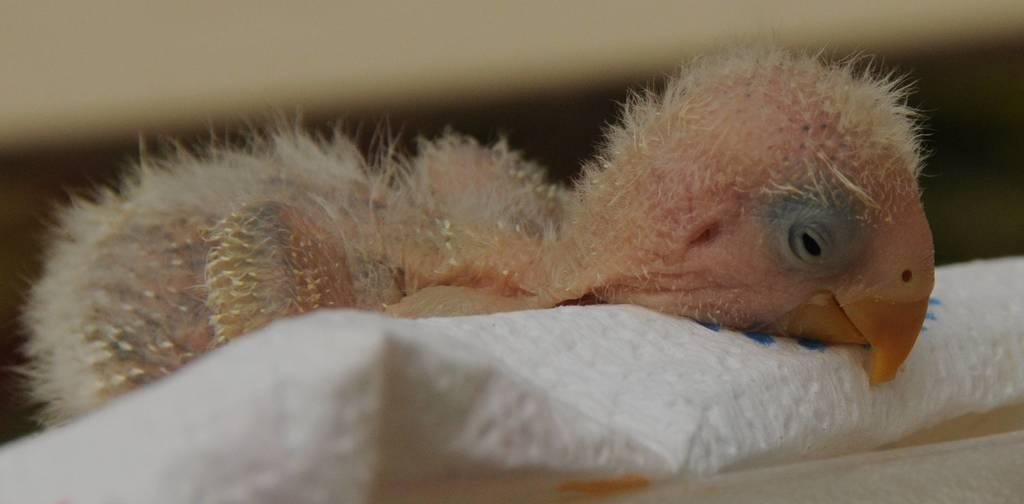What type of animal is in the image? There is a bird in the image. What is the bird standing on in the image? The bird is on a white surface. How many frogs are sitting on the paper in the image? There are no frogs or paper present in the image; it only features a bird on a white surface. 